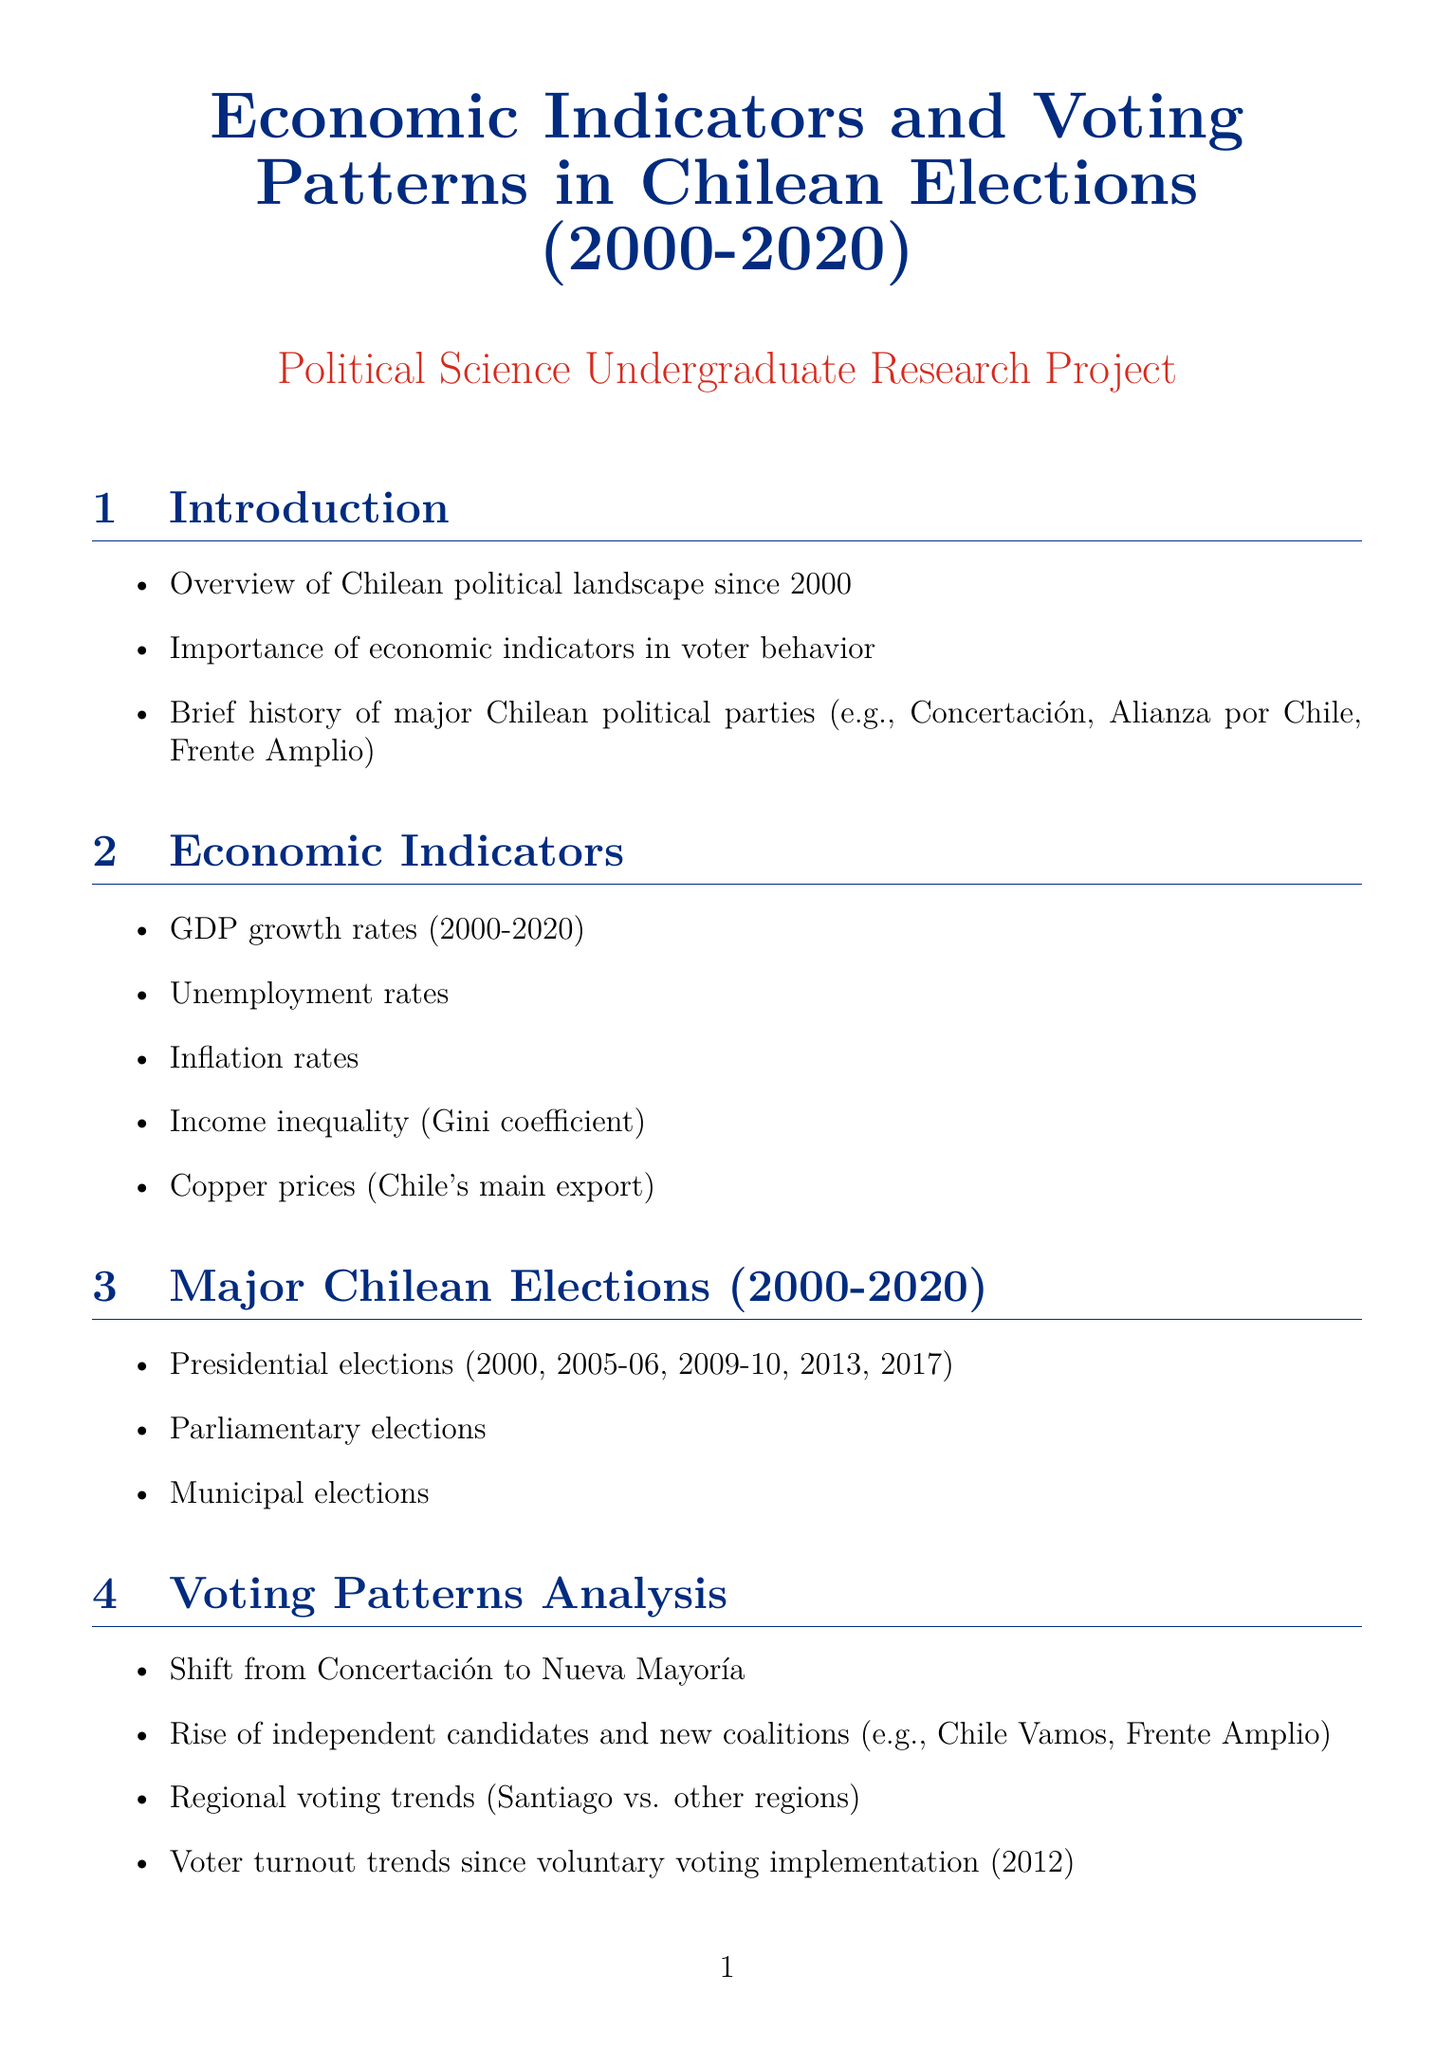What is the focus of the report? The report focuses on the examination of the relationship between economic indicators and voting patterns in Chilean elections over the past two decades.
Answer: Relationship between economic indicators and voting patterns Which years are included in the statistical analysis section? The statistical analysis section includes correlations and regression analyses from the overall election cycle and economic performance from 2000 to 2020.
Answer: 2000-2020 What significant change in voter turnout occurred after 2012? Since 2012, Chile implemented voluntary voting leading to changes in voter engagement and turnout trends.
Answer: Voluntary voting implementation In which election did Sebastián Piñera first win? Sebastián Piñera first won the presidential election in 2009-10 following the economic recovery post the 2008 crisis.
Answer: 2009-10 election What economic indicator is represented by the Gini coefficient? The Gini coefficient represents income inequality among Chile's population, a key economic indicator discussed in the report.
Answer: Income inequality Who is one of the potential interviewees mentioned in the report? Claudia Heiss is noted as a potential interviewee, indicating her expertise in political science relevant to the report's topic.
Answer: Claudia Heiss What theory is discussed in the theoretical framework section? Economic voting theory is one of the key theories discussed in evaluating voter behavior in response to economic conditions.
Answer: Economic voting theory What main political coalition emerged as a result of the shift in voter support from Concertación? The Nueva Mayoría coalition emerged following the shift in voter support from the Concertación party.
Answer: Nueva Mayoría Which two Latin American countries are compared with Chile in the document? Chile's voting patterns are compared with Argentina and Brazil to explore similarities and differences in economic voting behavior.
Answer: Argentina, Brazil 